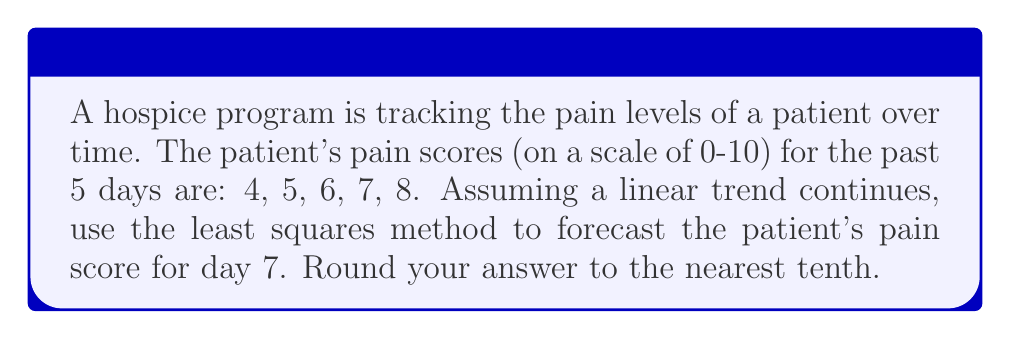Show me your answer to this math problem. To forecast the patient's pain score using the least squares method, we'll follow these steps:

1) Let's define our variables:
   $x$: day number (1, 2, 3, 4, 5)
   $y$: pain score (4, 5, 6, 7, 8)

2) We need to calculate the following sums:
   $n = 5$ (number of data points)
   $\sum x = 1 + 2 + 3 + 4 + 5 = 15$
   $\sum y = 4 + 5 + 6 + 7 + 8 = 30$
   $\sum xy = (1)(4) + (2)(5) + (3)(6) + (4)(7) + (5)(8) = 110$
   $\sum x^2 = 1^2 + 2^2 + 3^2 + 4^2 + 5^2 = 55$

3) Use these formulas to calculate the slope (m) and y-intercept (b):

   $$m = \frac{n\sum xy - \sum x \sum y}{n\sum x^2 - (\sum x)^2}$$

   $$b = \frac{\sum y - m\sum x}{n}$$

4) Plug in our values:

   $$m = \frac{5(110) - 15(30)}{5(55) - 15^2} = \frac{550 - 450}{275 - 225} = \frac{100}{50} = 2$$

   $$b = \frac{30 - 2(15)}{5} = \frac{30 - 30}{5} = 0$$

5) Our linear equation is therefore:
   $y = 2x + 0$ or simply $y = 2x$

6) To forecast for day 7, we substitute $x = 7$:
   $y = 2(7) = 14$

However, since pain scores are on a scale of 0-10, we need to cap this at 10.
Answer: 10 